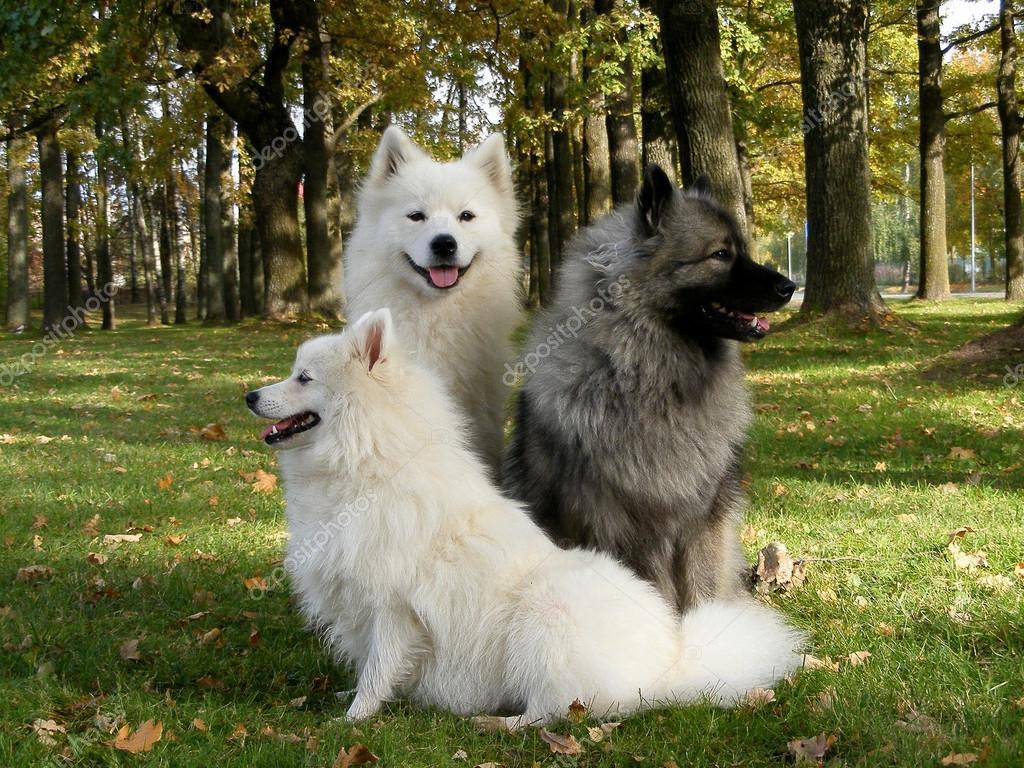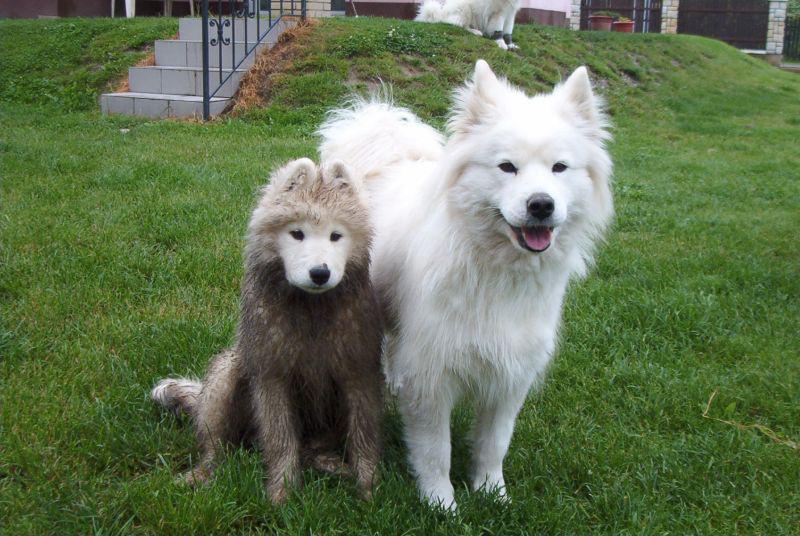The first image is the image on the left, the second image is the image on the right. Given the left and right images, does the statement "There is a ball or a backpack in atleast one of the pictures." hold true? Answer yes or no. No. The first image is the image on the left, the second image is the image on the right. Evaluate the accuracy of this statement regarding the images: "At least one dog is sitting and one image has exactly 2 dogs.". Is it true? Answer yes or no. Yes. 